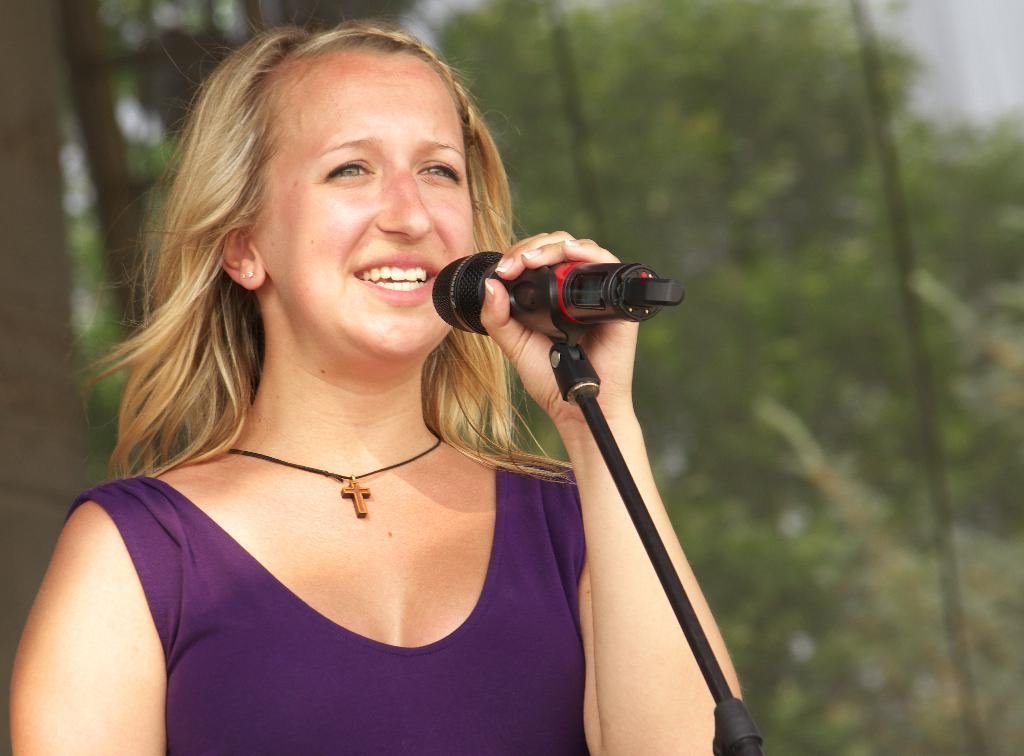Who is the main subject in the image? There is a woman in the image. What is the woman holding in the image? The woman is holding a mic. What might the woman be doing with the mic? The woman might be singing. What can be seen in the background of the image? There are trees in the background of the image. What year is depicted in the image? The image does not depict a specific year; it is a photograph of a woman holding a mic. Can you see a nest in the image? There is no nest present in the image; it features a woman holding a mic with trees in the background. 